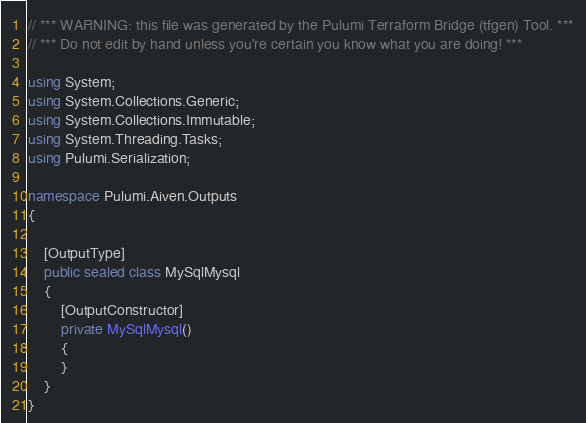<code> <loc_0><loc_0><loc_500><loc_500><_C#_>// *** WARNING: this file was generated by the Pulumi Terraform Bridge (tfgen) Tool. ***
// *** Do not edit by hand unless you're certain you know what you are doing! ***

using System;
using System.Collections.Generic;
using System.Collections.Immutable;
using System.Threading.Tasks;
using Pulumi.Serialization;

namespace Pulumi.Aiven.Outputs
{

    [OutputType]
    public sealed class MySqlMysql
    {
        [OutputConstructor]
        private MySqlMysql()
        {
        }
    }
}
</code> 